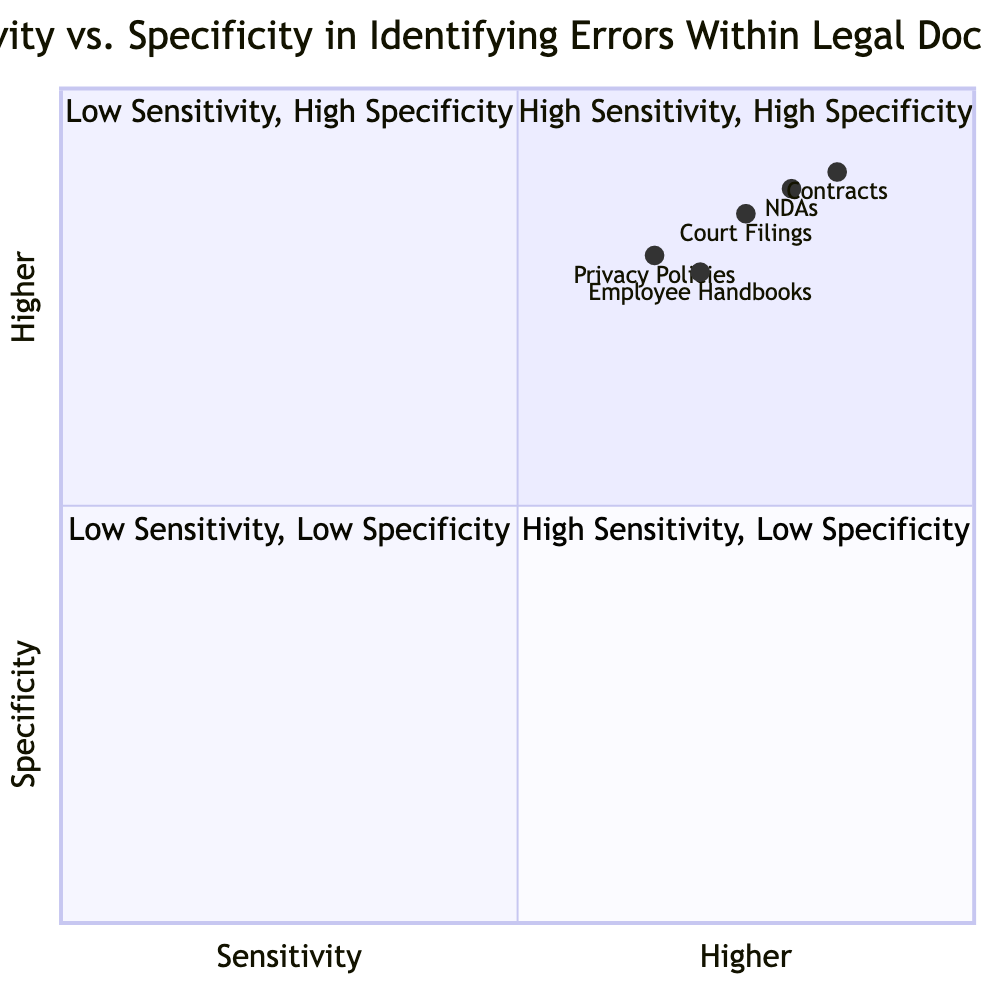What is the sensitivity value for Contracts? The diagram indicates that the sensitivity for Contracts is listed as 0.85 on the x-axis.
Answer: 0.85 What is the specificity value for Non-Disclosure Agreements (NDAs)? The diagram shows that NDAs have a specificity value of 0.88, which can be found on the y-axis line for that document type.
Answer: 0.88 Which document type has the highest sensitivity? By comparing the sensitivity values provided, Contracts has the highest sensitivity at 0.85, which is greater than all other document types listed.
Answer: Contracts In which quadrant would Privacy Policies be categorized? The sensitivity for Privacy Policies is 0.65, and the specificity is 0.80. This places it in the "High Sensitivity, Low Specificity" quadrant because the sensitivity is lower than the others but still higher than the lowest sensitivity group.
Answer: High Sensitivity, Low Specificity How many document types fall in the High Sensitivity, High Specificity quadrant? Contracts and Non-Disclosure Agreements (NDAs) fall within the "High Sensitivity, High Specificity" quadrant based on their sensitivity and specificity values.
Answer: 2 What is the average specificity for all document types? To find the average specificity, add up the specificity values (0.90 + 0.88 + 0.85 + 0.78 + 0.80 = 4.21) and then divide by the number of document types (5). This gives an average specificity of 0.842.
Answer: 0.842 Which document type has the lowest sensitivity rate? Comparing the sensitivity values, Privacy Policies at 0.65 have the lowest sensitivity of all the listed document types, indicating it is the least sensitive to errors.
Answer: Privacy Policies What quadrant contains Court Filings? The sensitivity for Court Filings is 0.75, and the specificity is 0.85. This places it in the "High Sensitivity, High Specificity" quadrant, as its values are high enough compared to the thresholds defined.
Answer: High Sensitivity, High Specificity How does the specificity of Employee Handbooks compare to that of Privacy Policies? The specificity for Employee Handbooks (0.78) is lower than that of Privacy Policies (0.80), indicating that Employee Handbooks are slightly less specific in identifying accurate legal text.
Answer: Lower 